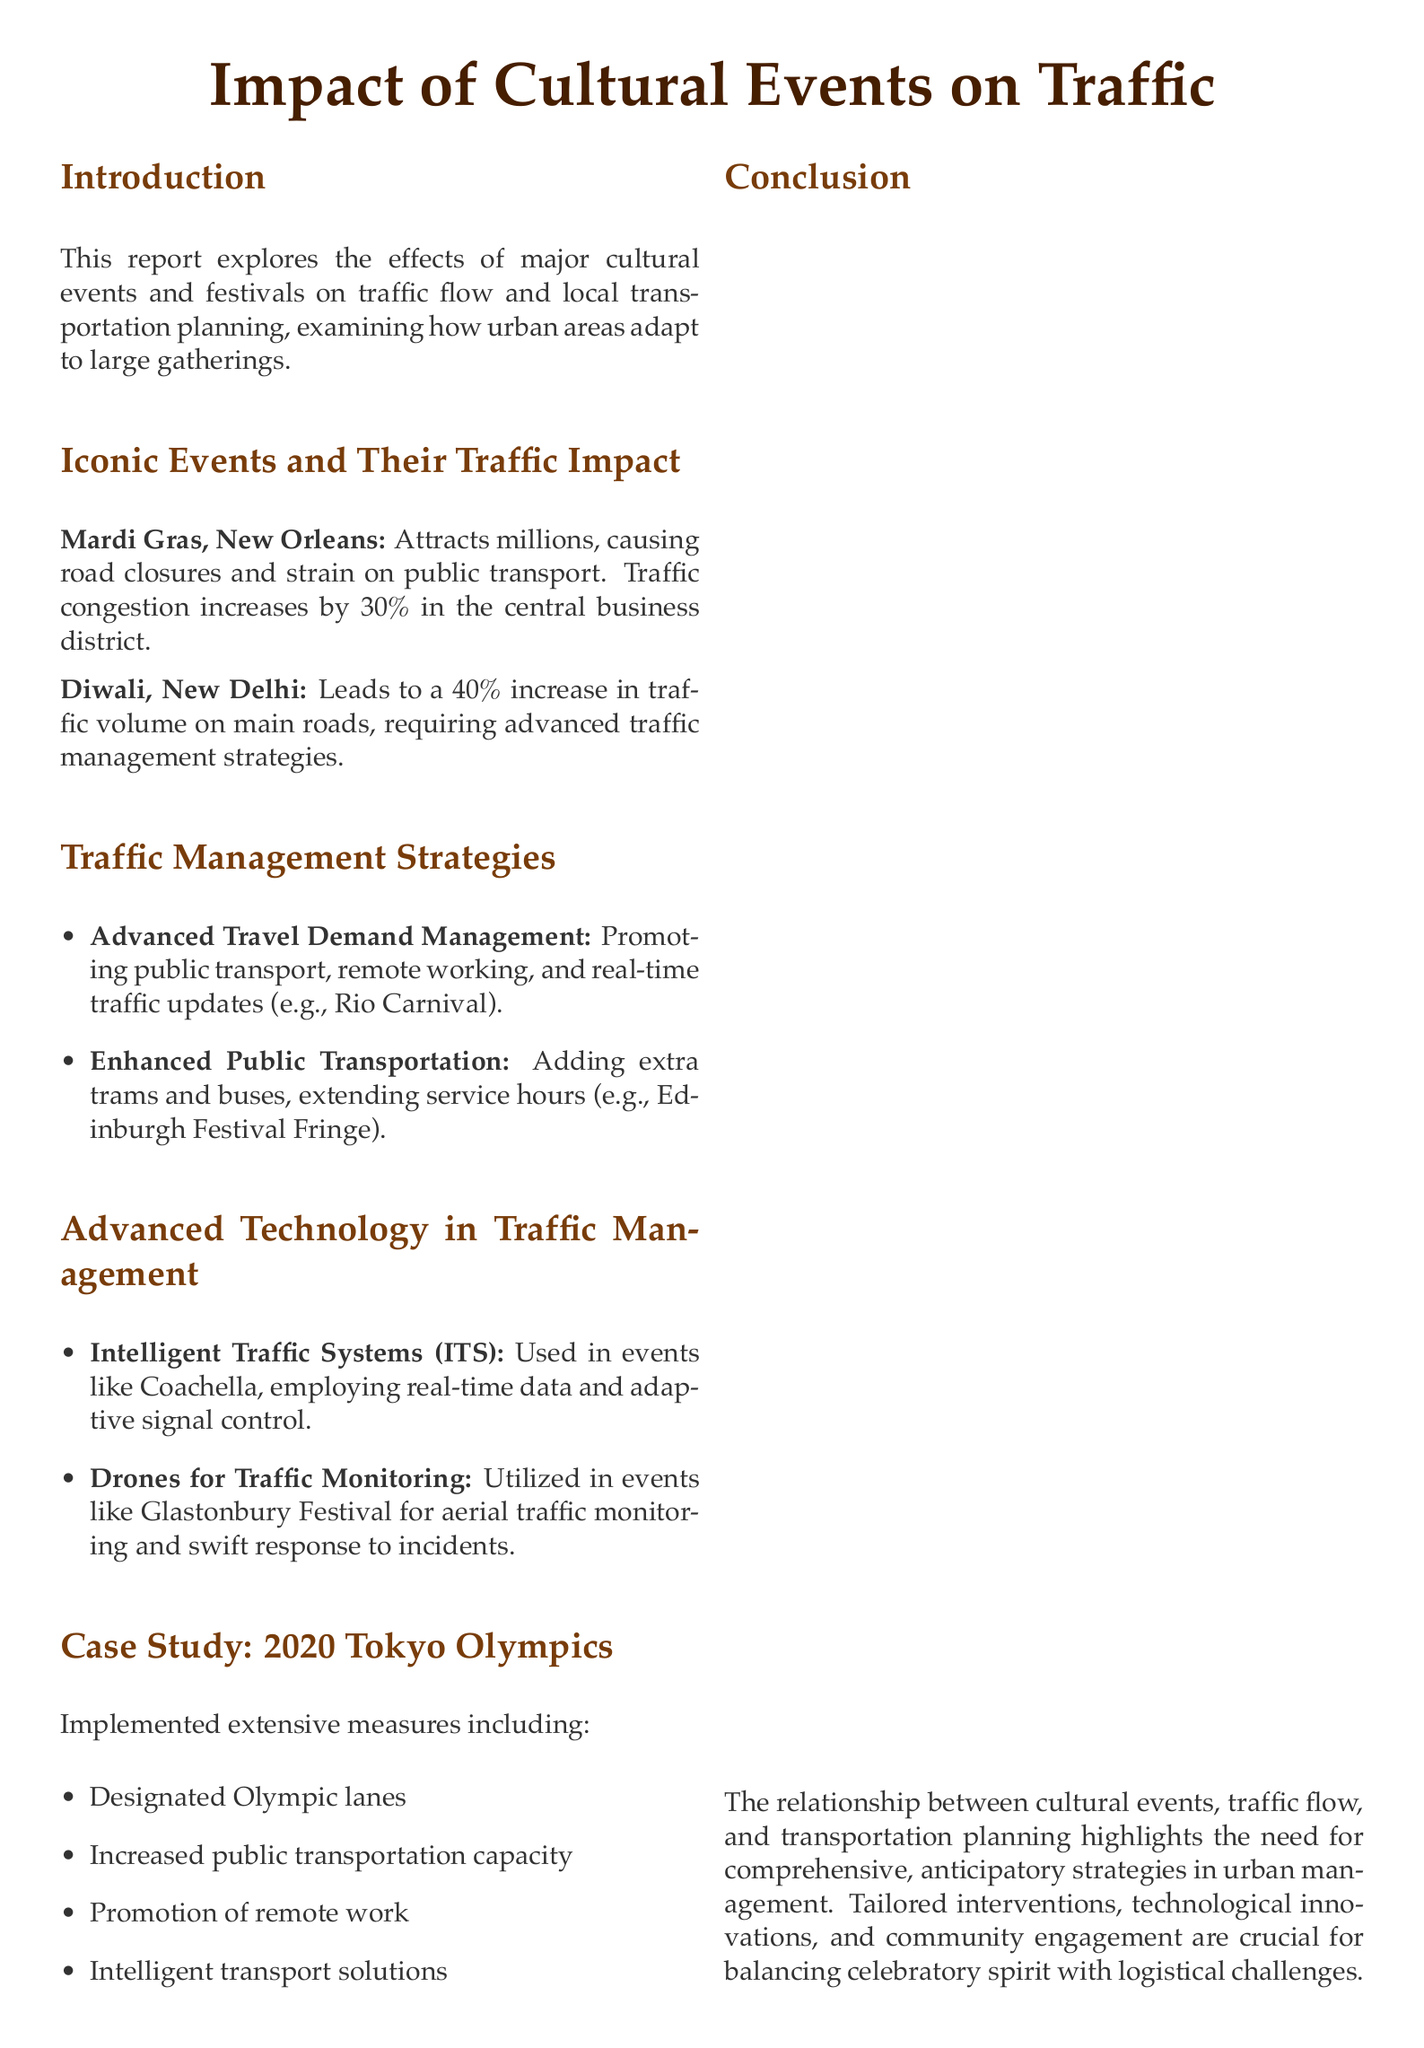What is the main focus of the report? The report focuses on the effects of major cultural events and festivals on traffic flow and local transportation planning.
Answer: Impact of cultural events on traffic What percentage increase in traffic does Mardi Gras cause in the central business district? The document specifies that Mardi Gras traffic congestion increases by 30%.
Answer: 30% What event is associated with a 40% increase in traffic volume? The report indicates that Diwali in New Delhi leads to a 40% increase in traffic volume.
Answer: Diwali What technology is used for real-time data during events like Coachella? The document mentions Intelligent Traffic Systems (ITS) as the technology used in events like Coachella.
Answer: Intelligent Traffic Systems (ITS) What was one measure implemented for the 2020 Tokyo Olympics? The document lists several measures, including designated Olympic lanes, as part of the traffic management strategy.
Answer: Designated Olympic lanes How does the report describe the relationship between cultural events and transportation? The report indicates the need for comprehensive, anticipatory strategies in urban management due to the relationship between cultural events and transportation planning.
Answer: Comprehensive, anticipatory strategies What type of additional public transport was mentioned for events like the Edinburgh Festival Fringe? The document states that enhanced public transportation included adding extra trams and buses.
Answer: Extra trams and buses What innovative tool is mentioned for traffic monitoring at Glastonbury Festival? Drones are highlighted as the innovative tool used for traffic monitoring during the Glastonbury Festival.
Answer: Drones What is the conclusion drawn in the report? The report concludes that tailored interventions, technological innovations, and community engagement are crucial for balancing celebratory spirit with logistical challenges.
Answer: Tailored interventions, technological innovations, and community engagement 